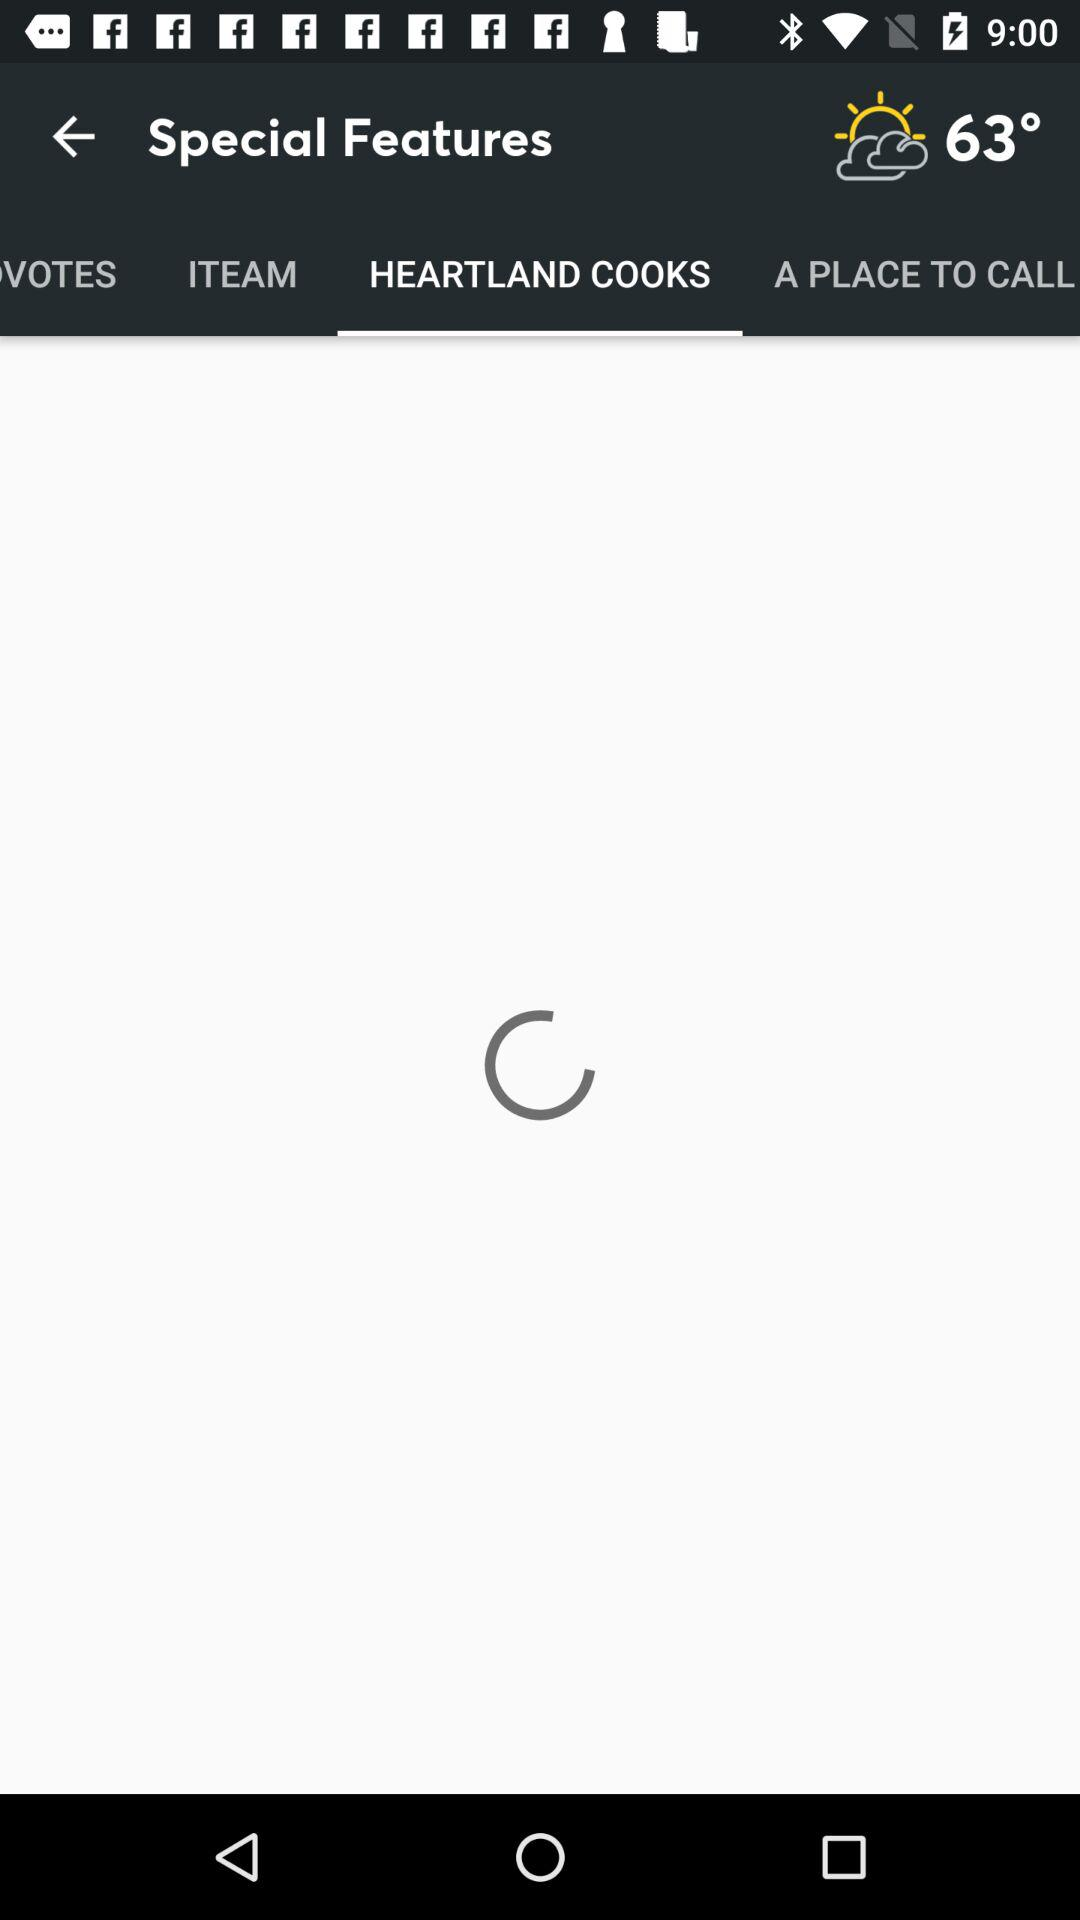Which is the selected tab? The selected tab is "HEARTLAND COOKS". 